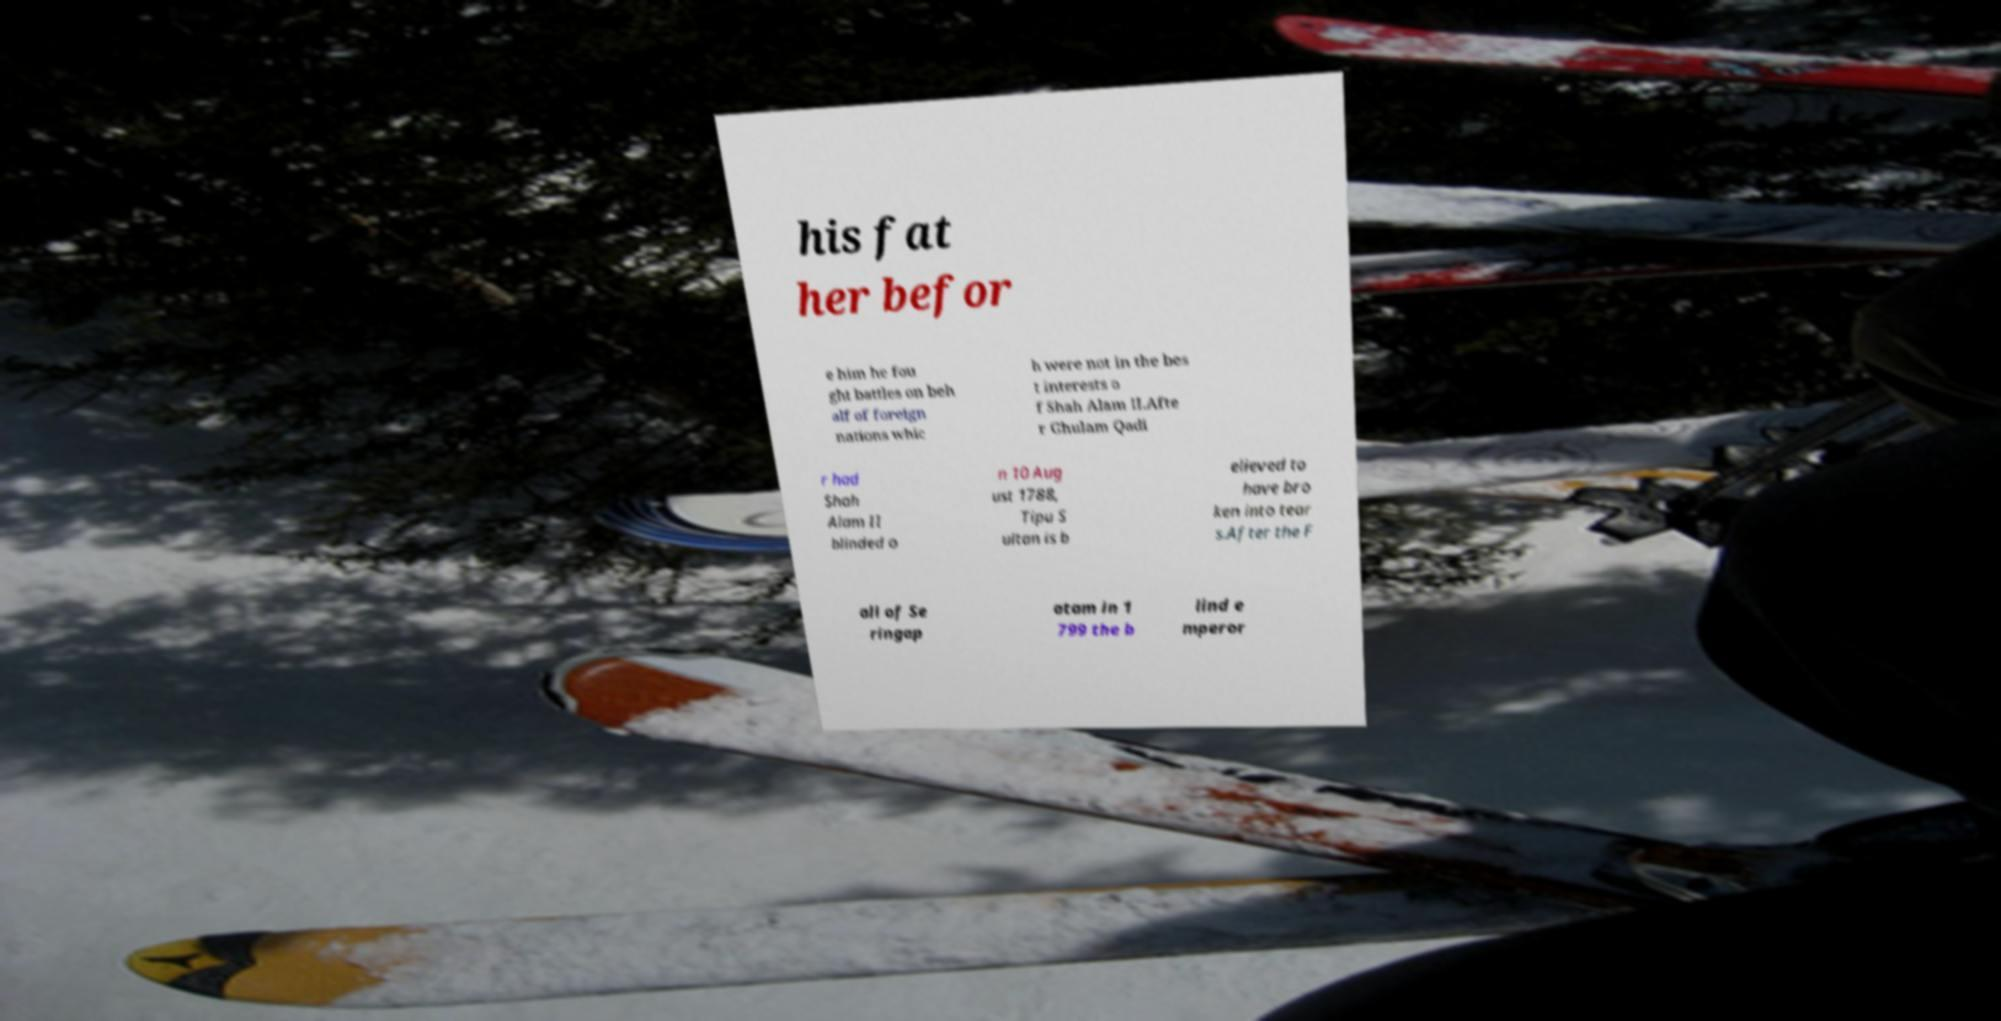For documentation purposes, I need the text within this image transcribed. Could you provide that? his fat her befor e him he fou ght battles on beh alf of foreign nations whic h were not in the bes t interests o f Shah Alam II.Afte r Ghulam Qadi r had Shah Alam II blinded o n 10 Aug ust 1788, Tipu S ultan is b elieved to have bro ken into tear s.After the F all of Se ringap atam in 1 799 the b lind e mperor 